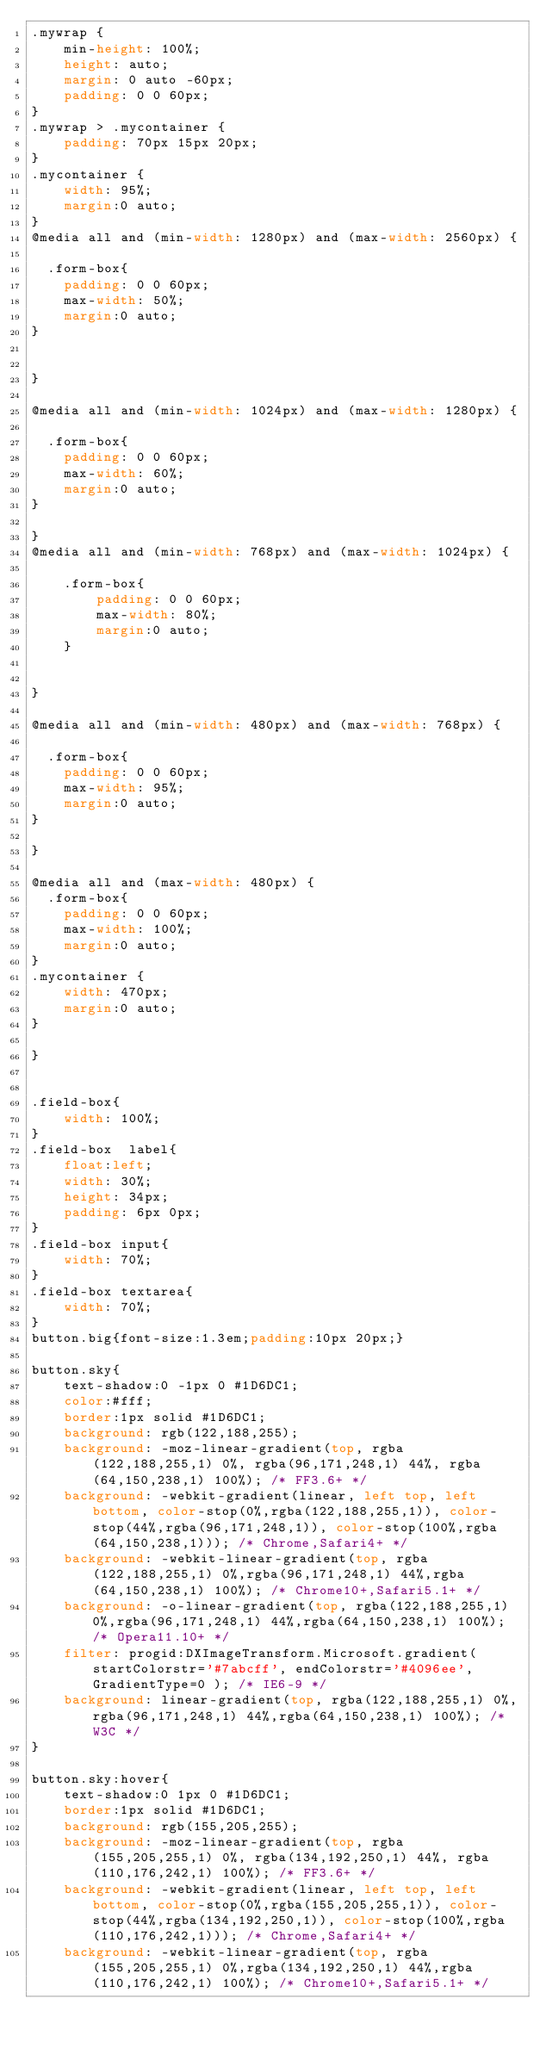<code> <loc_0><loc_0><loc_500><loc_500><_CSS_>.mywrap {
    min-height: 100%;
    height: auto;
    margin: 0 auto -60px;
    padding: 0 0 60px;
}
.mywrap > .mycontainer {
    padding: 70px 15px 20px;
}
.mycontainer {
    width: 95%;
    margin:0 auto;
} 
@media all and (min-width: 1280px) and (max-width: 2560px) {

  .form-box{
    padding: 0 0 60px;
    max-width: 50%;
    margin:0 auto;
} 


}

@media all and (min-width: 1024px) and (max-width: 1280px) {

  .form-box{
    padding: 0 0 60px;
    max-width: 60%;
    margin:0 auto;
}

}
@media all and (min-width: 768px) and (max-width: 1024px) {

    .form-box{
        padding: 0 0 60px;
        max-width: 80%;
        margin:0 auto;
    }

    
}

@media all and (min-width: 480px) and (max-width: 768px) {

  .form-box{
    padding: 0 0 60px;
    max-width: 95%;
    margin:0 auto;
} 

}

@media all and (max-width: 480px) {
  .form-box{
    padding: 0 0 60px;
    max-width: 100%;
    margin:0 auto;
}
.mycontainer {
    width: 470px;
    margin:0 auto;
} 
  
}


.field-box{
    width: 100%;
}
.field-box  label{
    float:left;
    width: 30%;
    height: 34px;
    padding: 6px 0px;
}
.field-box input{
    width: 70%;
}
.field-box textarea{
    width: 70%;
}
button.big{font-size:1.3em;padding:10px 20px;}

button.sky{
    text-shadow:0 -1px 0 #1D6DC1;
    color:#fff;
    border:1px solid #1D6DC1;
    background: rgb(122,188,255);
    background: -moz-linear-gradient(top, rgba(122,188,255,1) 0%, rgba(96,171,248,1) 44%, rgba(64,150,238,1) 100%); /* FF3.6+ */
    background: -webkit-gradient(linear, left top, left bottom, color-stop(0%,rgba(122,188,255,1)), color-stop(44%,rgba(96,171,248,1)), color-stop(100%,rgba(64,150,238,1))); /* Chrome,Safari4+ */
    background: -webkit-linear-gradient(top, rgba(122,188,255,1) 0%,rgba(96,171,248,1) 44%,rgba(64,150,238,1) 100%); /* Chrome10+,Safari5.1+ */
    background: -o-linear-gradient(top, rgba(122,188,255,1) 0%,rgba(96,171,248,1) 44%,rgba(64,150,238,1) 100%); /* Opera11.10+ */
    filter: progid:DXImageTransform.Microsoft.gradient( startColorstr='#7abcff', endColorstr='#4096ee',GradientType=0 ); /* IE6-9 */
    background: linear-gradient(top, rgba(122,188,255,1) 0%,rgba(96,171,248,1) 44%,rgba(64,150,238,1) 100%); /* W3C */
}

button.sky:hover{
    text-shadow:0 1px 0 #1D6DC1;
    border:1px solid #1D6DC1;
    background: rgb(155,205,255);
    background: -moz-linear-gradient(top, rgba(155,205,255,1) 0%, rgba(134,192,250,1) 44%, rgba(110,176,242,1) 100%); /* FF3.6+ */
    background: -webkit-gradient(linear, left top, left bottom, color-stop(0%,rgba(155,205,255,1)), color-stop(44%,rgba(134,192,250,1)), color-stop(100%,rgba(110,176,242,1))); /* Chrome,Safari4+ */
    background: -webkit-linear-gradient(top, rgba(155,205,255,1) 0%,rgba(134,192,250,1) 44%,rgba(110,176,242,1) 100%); /* Chrome10+,Safari5.1+ */</code> 